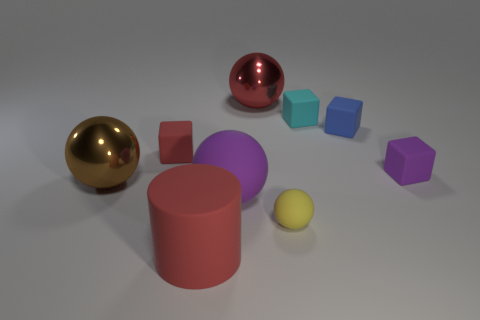Do the tiny red block and the large ball in front of the large brown sphere have the same material?
Your response must be concise. Yes. Is there any other thing of the same color as the matte cylinder?
Your answer should be compact. Yes. What number of objects are small objects behind the large brown shiny thing or tiny objects in front of the big purple ball?
Your answer should be very brief. 5. The red thing that is in front of the cyan thing and behind the red cylinder has what shape?
Provide a succinct answer. Cube. What number of balls are on the left side of the red block that is behind the purple rubber sphere?
Your answer should be compact. 1. Are there any other things that are the same material as the big brown sphere?
Keep it short and to the point. Yes. What number of objects are big balls that are left of the large red cylinder or shiny things?
Keep it short and to the point. 2. What size is the thing that is in front of the yellow matte thing?
Ensure brevity in your answer.  Large. What is the big red cylinder made of?
Give a very brief answer. Rubber. What shape is the red matte thing behind the red rubber object in front of the brown object?
Provide a succinct answer. Cube. 